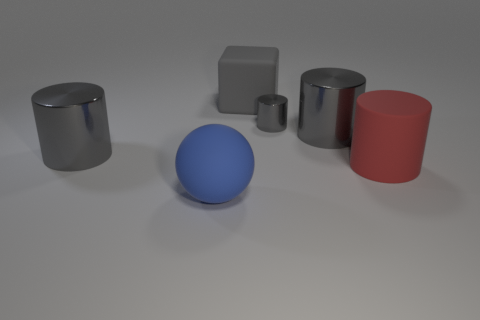The red rubber cylinder has what size?
Provide a succinct answer. Large. What number of red cylinders are to the right of the big rubber object that is in front of the big red rubber cylinder that is on the right side of the big blue rubber sphere?
Your response must be concise. 1. Are there any other things that are the same color as the tiny metal cylinder?
Your answer should be very brief. Yes. Does the shiny object that is on the left side of the rubber sphere have the same color as the large metallic object that is right of the large blue thing?
Make the answer very short. Yes. Are there more shiny cylinders that are in front of the tiny metal thing than rubber spheres that are to the left of the gray matte object?
Your answer should be compact. Yes. What is the material of the big sphere?
Your response must be concise. Rubber. There is a big matte thing that is in front of the cylinder to the right of the big gray metallic cylinder right of the large blue matte thing; what is its shape?
Ensure brevity in your answer.  Sphere. What number of other objects are the same material as the block?
Your response must be concise. 2. Are the cylinder on the left side of the small gray shiny cylinder and the red cylinder that is behind the blue object made of the same material?
Make the answer very short. No. What number of things are behind the sphere and in front of the rubber cylinder?
Ensure brevity in your answer.  0. 